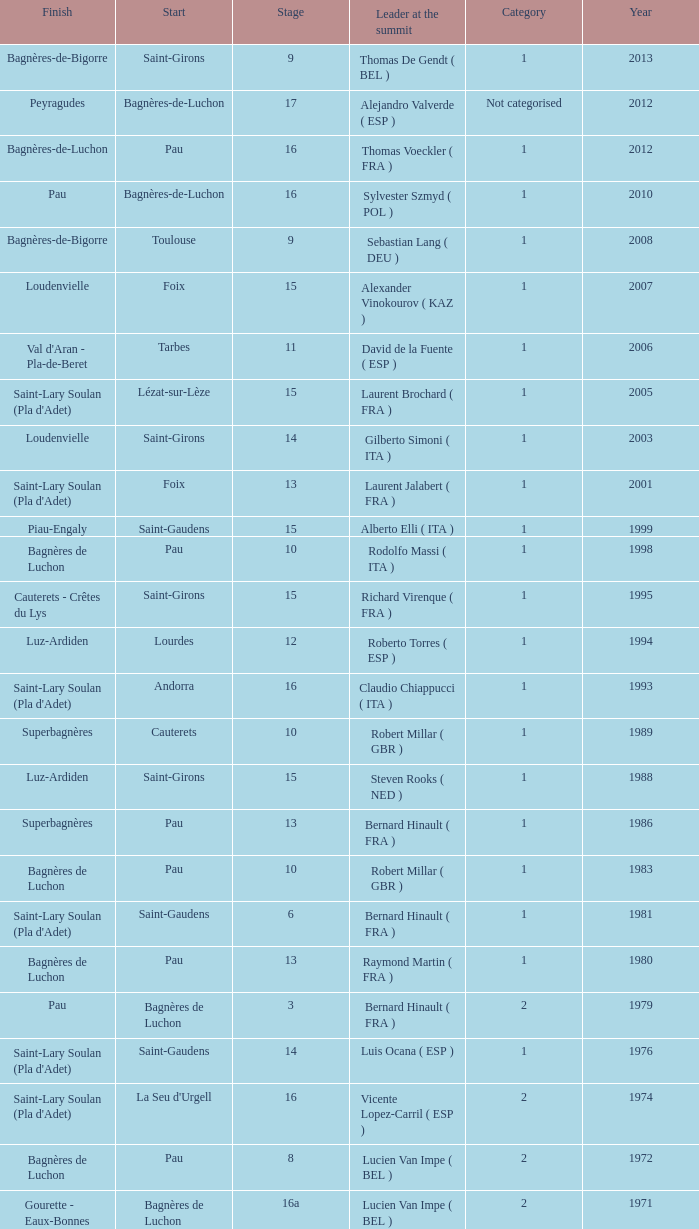What category was in 1964? 2.0. Could you parse the entire table? {'header': ['Finish', 'Start', 'Stage', 'Leader at the summit', 'Category', 'Year'], 'rows': [['Bagnères-de-Bigorre', 'Saint-Girons', '9', 'Thomas De Gendt ( BEL )', '1', '2013'], ['Peyragudes', 'Bagnères-de-Luchon', '17', 'Alejandro Valverde ( ESP )', 'Not categorised', '2012'], ['Bagnères-de-Luchon', 'Pau', '16', 'Thomas Voeckler ( FRA )', '1', '2012'], ['Pau', 'Bagnères-de-Luchon', '16', 'Sylvester Szmyd ( POL )', '1', '2010'], ['Bagnères-de-Bigorre', 'Toulouse', '9', 'Sebastian Lang ( DEU )', '1', '2008'], ['Loudenvielle', 'Foix', '15', 'Alexander Vinokourov ( KAZ )', '1', '2007'], ["Val d'Aran - Pla-de-Beret", 'Tarbes', '11', 'David de la Fuente ( ESP )', '1', '2006'], ["Saint-Lary Soulan (Pla d'Adet)", 'Lézat-sur-Lèze', '15', 'Laurent Brochard ( FRA )', '1', '2005'], ['Loudenvielle', 'Saint-Girons', '14', 'Gilberto Simoni ( ITA )', '1', '2003'], ["Saint-Lary Soulan (Pla d'Adet)", 'Foix', '13', 'Laurent Jalabert ( FRA )', '1', '2001'], ['Piau-Engaly', 'Saint-Gaudens', '15', 'Alberto Elli ( ITA )', '1', '1999'], ['Bagnères de Luchon', 'Pau', '10', 'Rodolfo Massi ( ITA )', '1', '1998'], ['Cauterets - Crêtes du Lys', 'Saint-Girons', '15', 'Richard Virenque ( FRA )', '1', '1995'], ['Luz-Ardiden', 'Lourdes', '12', 'Roberto Torres ( ESP )', '1', '1994'], ["Saint-Lary Soulan (Pla d'Adet)", 'Andorra', '16', 'Claudio Chiappucci ( ITA )', '1', '1993'], ['Superbagnères', 'Cauterets', '10', 'Robert Millar ( GBR )', '1', '1989'], ['Luz-Ardiden', 'Saint-Girons', '15', 'Steven Rooks ( NED )', '1', '1988'], ['Superbagnères', 'Pau', '13', 'Bernard Hinault ( FRA )', '1', '1986'], ['Bagnères de Luchon', 'Pau', '10', 'Robert Millar ( GBR )', '1', '1983'], ["Saint-Lary Soulan (Pla d'Adet)", 'Saint-Gaudens', '6', 'Bernard Hinault ( FRA )', '1', '1981'], ['Bagnères de Luchon', 'Pau', '13', 'Raymond Martin ( FRA )', '1', '1980'], ['Pau', 'Bagnères de Luchon', '3', 'Bernard Hinault ( FRA )', '2', '1979'], ["Saint-Lary Soulan (Pla d'Adet)", 'Saint-Gaudens', '14', 'Luis Ocana ( ESP )', '1', '1976'], ["Saint-Lary Soulan (Pla d'Adet)", "La Seu d'Urgell", '16', 'Vicente Lopez-Carril ( ESP )', '2', '1974'], ['Bagnères de Luchon', 'Pau', '8', 'Lucien Van Impe ( BEL )', '2', '1972'], ['Gourette - Eaux-Bonnes', 'Bagnères de Luchon', '16a', 'Lucien Van Impe ( BEL )', '2', '1971'], ['La Mongie', 'Saint-Gaudens', '18', 'Raymond Delisle ( FRA )', '2', '1970'], ['Mourenx', 'La Mongie', '17', 'Joaquim Galera ( ESP )', '2', '1969'], ['Pau', 'Bagnères de Luchon', '16', 'Julio Jiménez ( ESP )', '2', '1964'], ['Bagnères de Luchon', 'Bagnères-de-Bigorre', '11', 'Federico Bahamontes ( ESP )', '2', '1963'], ['Saint-Gaudens', 'Pau', '12', 'Federico Bahamontes ( ESP )', '2', '1962'], ['Pau', 'Bagnères de Luchon', '17', 'Imerio Massignan ( ITA )', '2', '1961'], ['Bagnères de Luchon', 'Pau', '11', 'Kurt Gimmi ( SUI )', '1', '1960'], ['Saint-Gaudens', 'Bagnères-de-Bigorre', '11', 'Valentin Huot ( FRA )', '1', '1959'], ['Bagnères de Luchon', 'Pau', '14', 'Federico Bahamontes ( ESP )', '1', '1958'], ['Bagnères de Luchon', 'Pau', '12', 'Jean-Pierre Schmitz ( LUX )', 'Not categorised', '1956'], ['Saint-Gaudens', 'Toulouse', '17', 'Charly Gaul ( LUX )', '2', '1955'], ['Bagnères de Luchon', 'Pau', '12', 'Federico Bahamontes ( ESP )', '2', '1954'], ['Bagnères de Luchon', 'Cauterets', '11', 'Jean Robic ( FRA )', '2', '1953'], ['Bagnères-de-Bigorre', 'Toulouse', '17', 'Antonio Gelabert ( ESP )', '2', '1952'], ['Bagnères de Luchon', 'Tarbes', '14', 'Fausto Coppi ( ITA )', '2', '1951'], ['Bagnères de Luchon', 'Pau', '11', 'Jean Robic ( FRA )', '2', '1949'], ['Toulouse', 'Lourdes', '8', 'Jean Robic ( FRA )', '2', '1948'], ['Pau', 'Bagnères de Luchon', '15', 'Jean Robic ( FRA )', '1', '1947']]} 